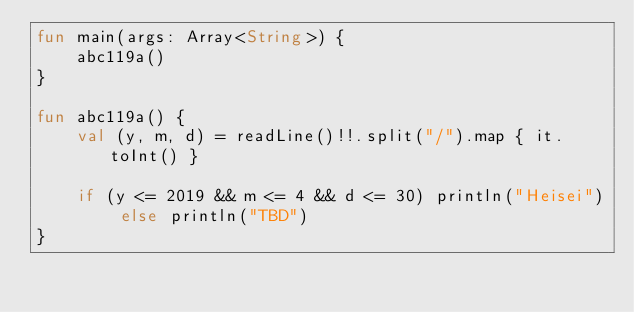Convert code to text. <code><loc_0><loc_0><loc_500><loc_500><_Kotlin_>fun main(args: Array<String>) {
    abc119a()
}

fun abc119a() {
    val (y, m, d) = readLine()!!.split("/").map { it.toInt() }
    
    if (y <= 2019 && m <= 4 && d <= 30) println("Heisei") else println("TBD")
}
</code> 